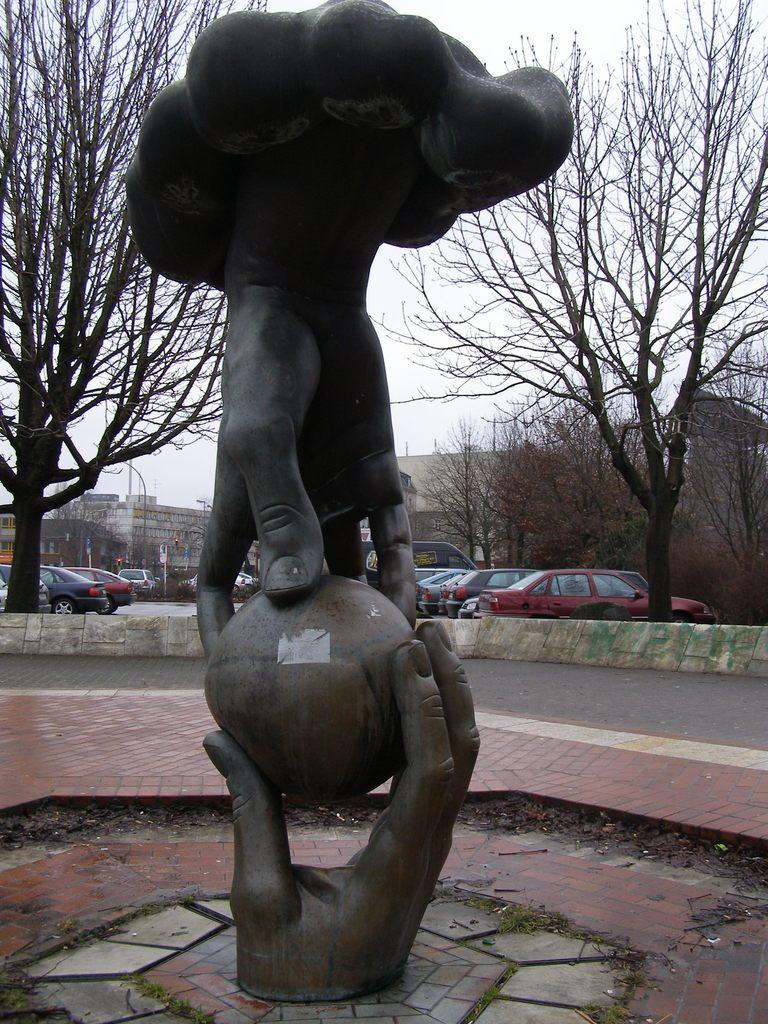What is the main subject in the image? There is a statue in the image. What can be seen behind the statue? There are trees, buildings, poles, and a wall behind the statue. What is visible in the sky in the image? The sky is visible in the image. What type of transportation can be seen on the road in the image? There are vehicles on the road in the image. What type of pie is being served to the minister in the image? There is no minister or pie present in the image. What is the statue made of, and does it resemble the earth? The material the statue is made of is not mentioned in the image, and it does not resemble the earth. 